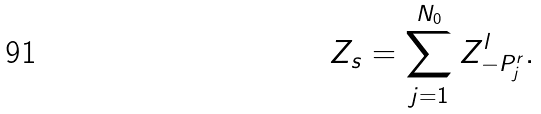Convert formula to latex. <formula><loc_0><loc_0><loc_500><loc_500>Z _ { s } = \sum _ { j = 1 } ^ { N _ { 0 } } Z ^ { l } _ { - P ^ { r } _ { j } } .</formula> 